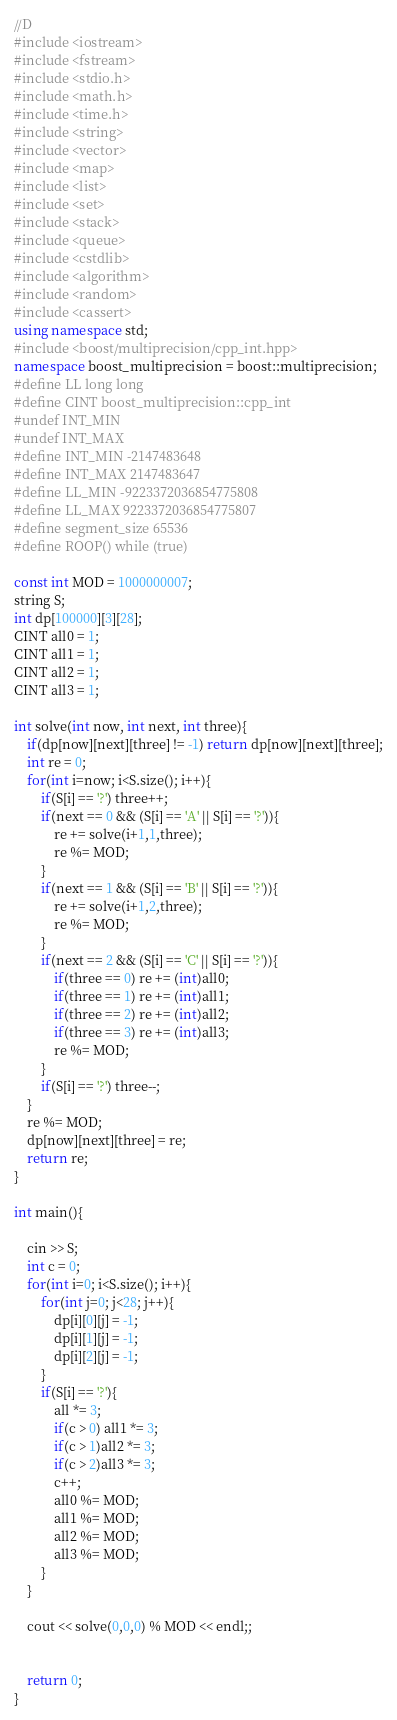Convert code to text. <code><loc_0><loc_0><loc_500><loc_500><_C++_>//D
#include <iostream>
#include <fstream>
#include <stdio.h>
#include <math.h>
#include <time.h>
#include <string>
#include <vector>
#include <map>
#include <list>
#include <set>
#include <stack>
#include <queue>
#include <cstdlib>
#include <algorithm>
#include <random>
#include <cassert>
using namespace std;
#include <boost/multiprecision/cpp_int.hpp>
namespace boost_multiprecision = boost::multiprecision;
#define LL long long
#define CINT boost_multiprecision::cpp_int
#undef INT_MIN
#undef INT_MAX
#define INT_MIN -2147483648
#define INT_MAX 2147483647
#define LL_MIN -9223372036854775808
#define LL_MAX 9223372036854775807
#define segment_size 65536
#define ROOP() while (true)

const int MOD = 1000000007;
string S;
int dp[100000][3][28];
CINT all0 = 1;
CINT all1 = 1;
CINT all2 = 1;
CINT all3 = 1;

int solve(int now, int next, int three){
    if(dp[now][next][three] != -1) return dp[now][next][three];
    int re = 0;
    for(int i=now; i<S.size(); i++){
        if(S[i] == '?') three++;
        if(next == 0 && (S[i] == 'A' || S[i] == '?')){
            re += solve(i+1,1,three);
            re %= MOD;
        }
        if(next == 1 && (S[i] == 'B' || S[i] == '?')){
            re += solve(i+1,2,three);
            re %= MOD;
        }
        if(next == 2 && (S[i] == 'C' || S[i] == '?')){
            if(three == 0) re += (int)all0;
            if(three == 1) re += (int)all1;
            if(three == 2) re += (int)all2;
            if(three == 3) re += (int)all3;
            re %= MOD;
        }
        if(S[i] == '?') three--;
    }
    re %= MOD;
    dp[now][next][three] = re;
    return re;
}

int main(){
    
    cin >> S;
    int c = 0;
    for(int i=0; i<S.size(); i++){
        for(int j=0; j<28; j++){
            dp[i][0][j] = -1;
            dp[i][1][j] = -1;
            dp[i][2][j] = -1;
        }
        if(S[i] == '?'){
            all *= 3;
            if(c > 0) all1 *= 3;
            if(c > 1)all2 *= 3;
            if(c > 2)all3 *= 3;
            c++;
            all0 %= MOD;
            all1 %= MOD;
            all2 %= MOD;
            all3 %= MOD;
        }
    }

    cout << solve(0,0,0) % MOD << endl;;

    
    return 0;
}</code> 